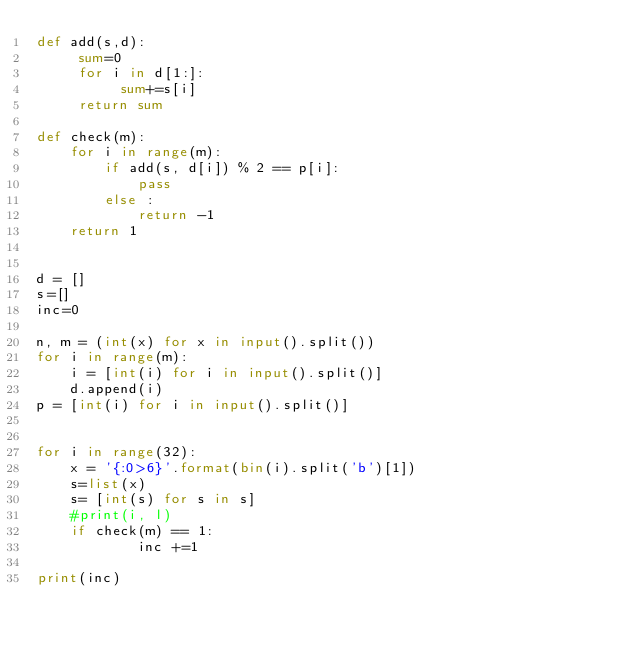Convert code to text. <code><loc_0><loc_0><loc_500><loc_500><_Python_>def add(s,d):
     sum=0
     for i in d[1:]:
          sum+=s[i] 
     return sum

def check(m):
    for i in range(m):
        if add(s, d[i]) % 2 == p[i]:
            pass
        else :
            return -1
    return 1
        
        
d = []
s=[]
inc=0

n, m = (int(x) for x in input().split())
for i in range(m):
    i = [int(i) for i in input().split()] 
    d.append(i)
p = [int(i) for i in input().split()]


for i in range(32):
    x = '{:0>6}'.format(bin(i).split('b')[1])
    s=list(x)
    s= [int(s) for s in s]
    #print(i, l)
    if check(m) == 1:
            inc +=1
    
print(inc)</code> 